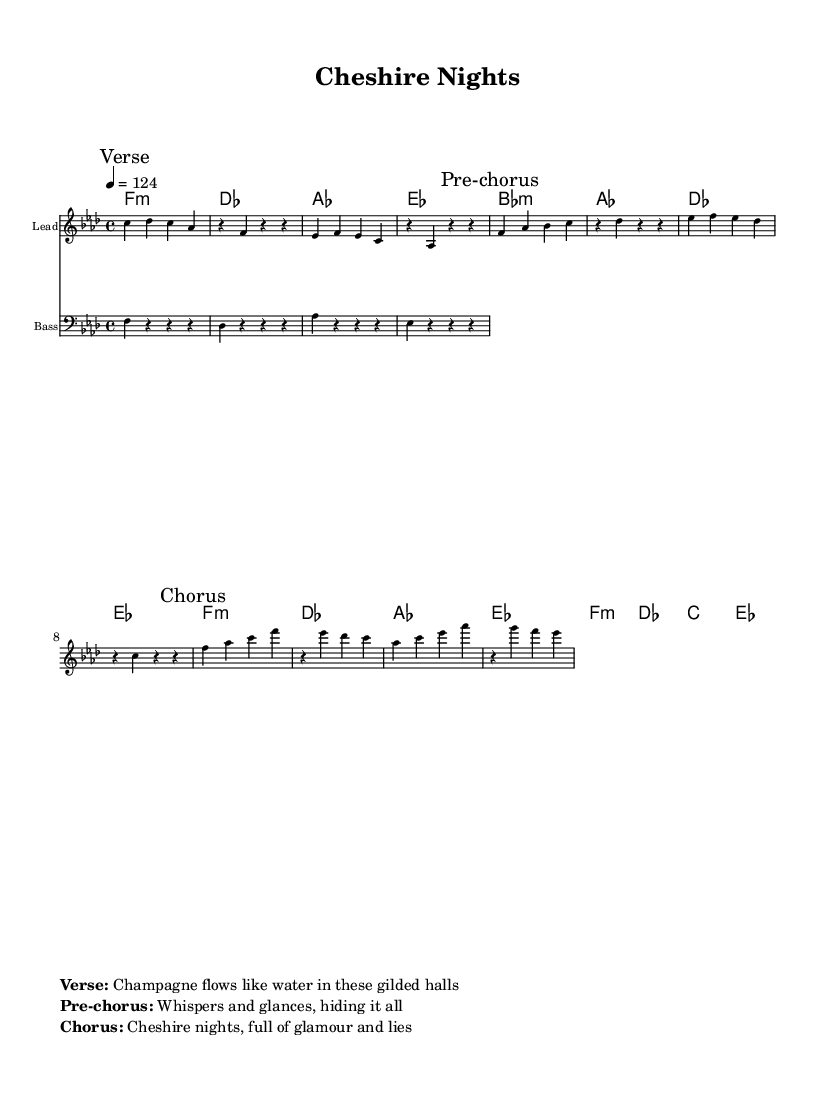What is the key signature of this music? The key signature is indicated at the beginning of the score and it shows an F minor key, which contains four flats.
Answer: F minor What is the time signature of this music? The time signature appears at the start of the sheet music, showing that the piece is in 4/4 time, meaning there are four beats per measure.
Answer: 4/4 What is the tempo marking for this piece? The tempo marking is located above the score and indicates that the piece should be played at a speed of 124 beats per minute.
Answer: 124 What is the first line of the verse lyrics? The verse lyrics are found in the markup section of the sheet music. The first line is "Champagne flows like water in these gilded halls."
Answer: "Champagne flows like water in these gilded halls." How many sections are there in this piece? The structure of the piece is indicated by the marked sections: Verse, Pre-chorus, and Chorus. Counting these gives a total of three distinct sections.
Answer: 3 What chord follows the E flat major in the harmony section? The chord sequence indicates the progression of chords played, and after E flat major, the next chord is B flat minor.
Answer: B flat minor What thematic elements are reflected in the song's lyrics? The lyrics discuss themes of romance and drama, particularly within affluent social contexts, as captured in phrases from the verse and chorus.
Answer: Romance and drama 